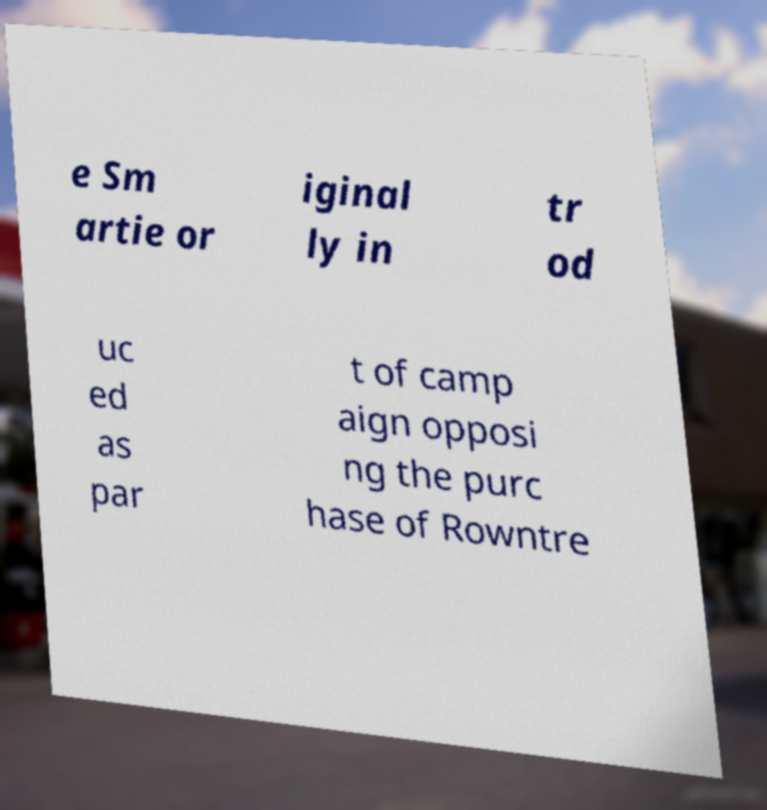Please read and relay the text visible in this image. What does it say? e Sm artie or iginal ly in tr od uc ed as par t of camp aign opposi ng the purc hase of Rowntre 